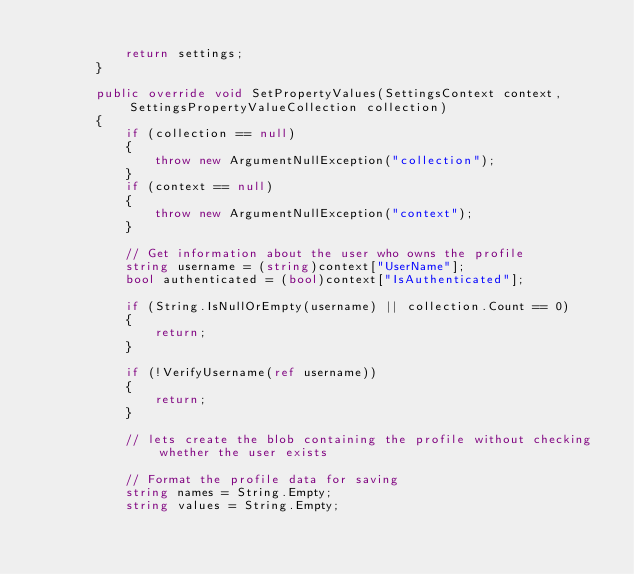<code> <loc_0><loc_0><loc_500><loc_500><_C#_>
            return settings;
        }

        public override void SetPropertyValues(SettingsContext context, SettingsPropertyValueCollection collection)
        {
            if (collection == null)
            {
                throw new ArgumentNullException("collection");
            }
            if (context == null)
            {
                throw new ArgumentNullException("context");
            }

            // Get information about the user who owns the profile
            string username = (string)context["UserName"];
            bool authenticated = (bool)context["IsAuthenticated"];

            if (String.IsNullOrEmpty(username) || collection.Count == 0)
            {
                return;
            }

            if (!VerifyUsername(ref username))
            {
                return;
            }

            // lets create the blob containing the profile without checking whether the user exists             

            // Format the profile data for saving
            string names = String.Empty;
            string values = String.Empty;</code> 